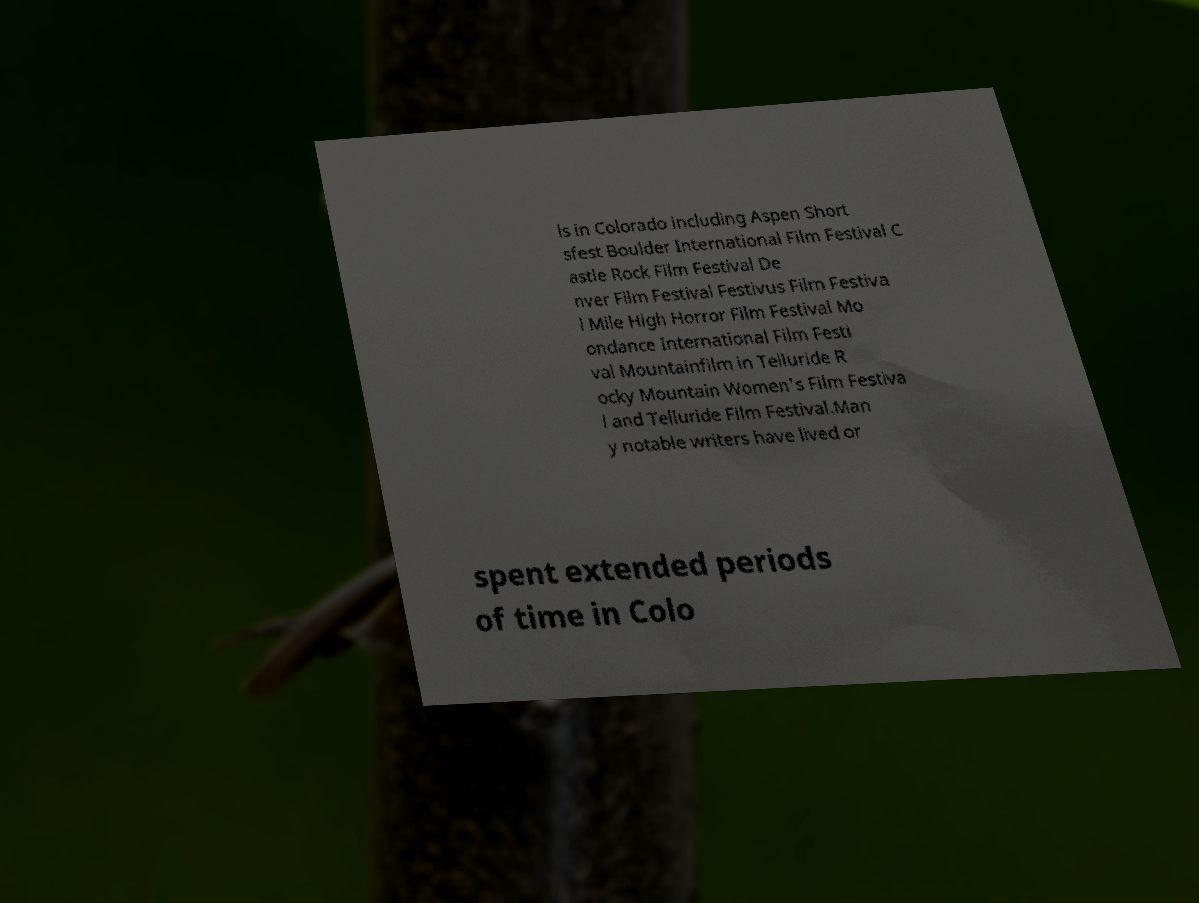Please identify and transcribe the text found in this image. ls in Colorado including Aspen Short sfest Boulder International Film Festival C astle Rock Film Festival De nver Film Festival Festivus Film Festiva l Mile High Horror Film Festival Mo ondance International Film Festi val Mountainfilm in Telluride R ocky Mountain Women's Film Festiva l and Telluride Film Festival.Man y notable writers have lived or spent extended periods of time in Colo 